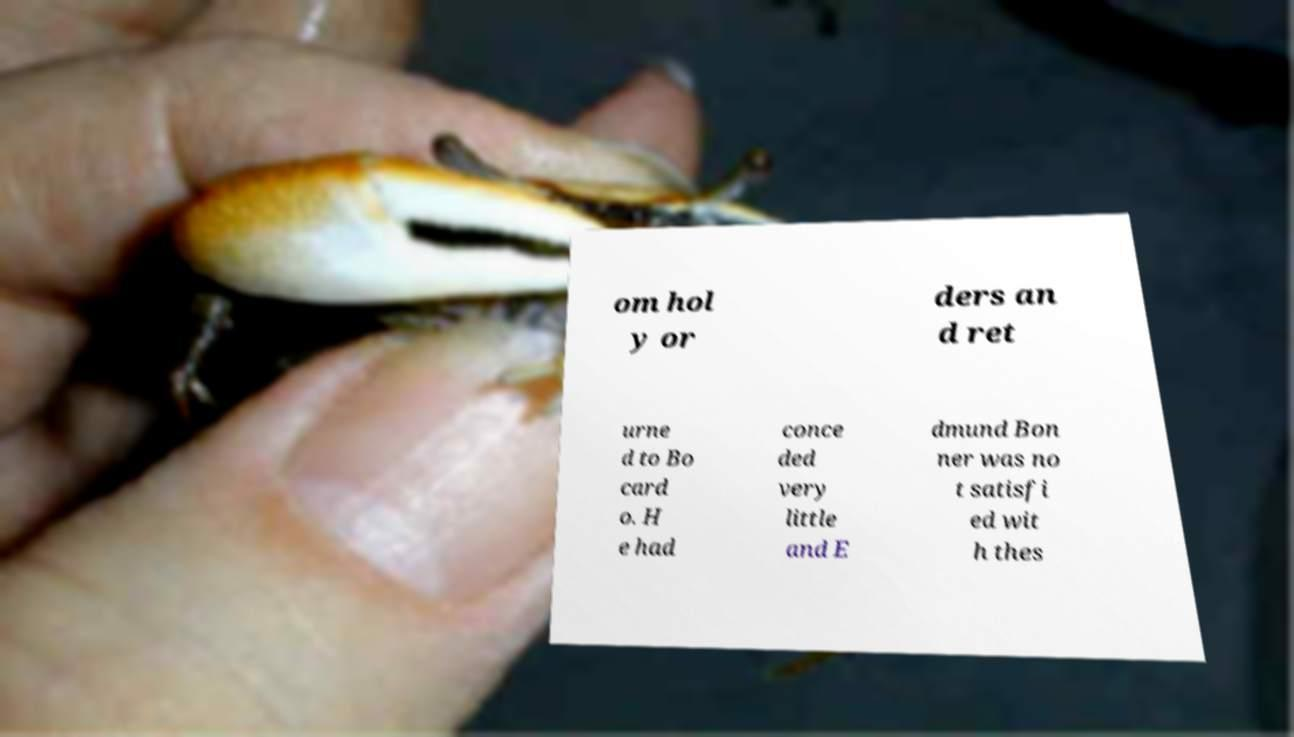For documentation purposes, I need the text within this image transcribed. Could you provide that? om hol y or ders an d ret urne d to Bo card o. H e had conce ded very little and E dmund Bon ner was no t satisfi ed wit h thes 